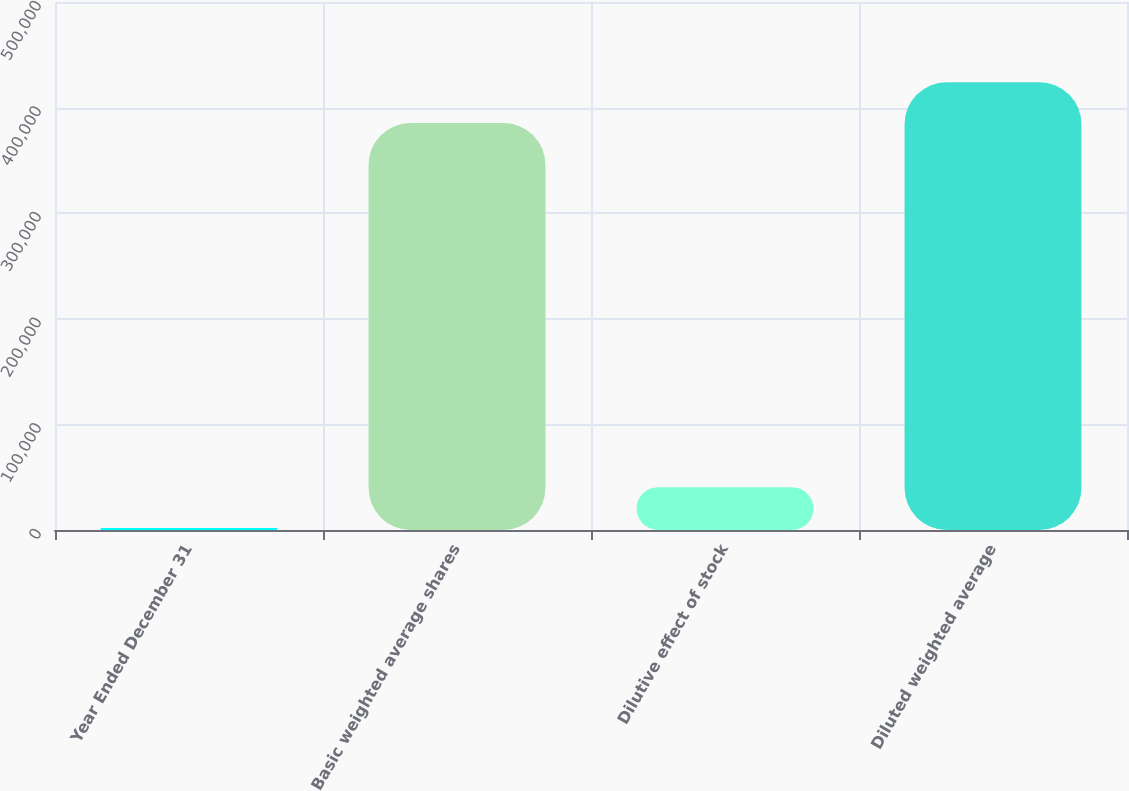Convert chart. <chart><loc_0><loc_0><loc_500><loc_500><bar_chart><fcel>Year Ended December 31<fcel>Basic weighted average shares<fcel>Dilutive effect of stock<fcel>Diluted weighted average<nl><fcel>2009<fcel>385475<fcel>40600.4<fcel>424066<nl></chart> 